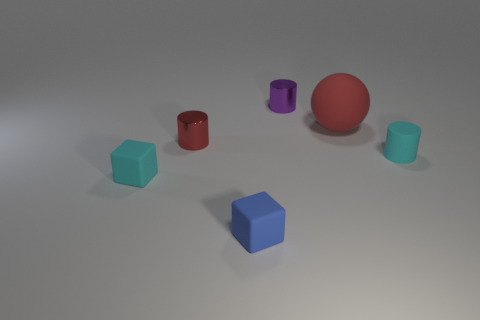What material is the other object that is the same color as the large matte object?
Offer a very short reply. Metal. What number of other things are there of the same color as the tiny matte cylinder?
Keep it short and to the point. 1. The metal cylinder that is on the right side of the thing that is in front of the cyan object in front of the cyan cylinder is what color?
Your response must be concise. Purple. Are there an equal number of purple metal objects in front of the red cylinder and small green metal blocks?
Provide a succinct answer. Yes. Is the size of the rubber thing that is behind the cyan cylinder the same as the blue cube?
Make the answer very short. No. How many tiny matte things are there?
Give a very brief answer. 3. What number of small metal things are both to the right of the red cylinder and in front of the red rubber ball?
Your response must be concise. 0. Are there any small red cylinders made of the same material as the tiny cyan cube?
Your answer should be compact. No. There is a small purple object right of the small cyan thing to the left of the cyan cylinder; what is it made of?
Offer a very short reply. Metal. Is the number of large things on the right side of the cyan rubber cylinder the same as the number of red shiny cylinders right of the red cylinder?
Ensure brevity in your answer.  Yes. 